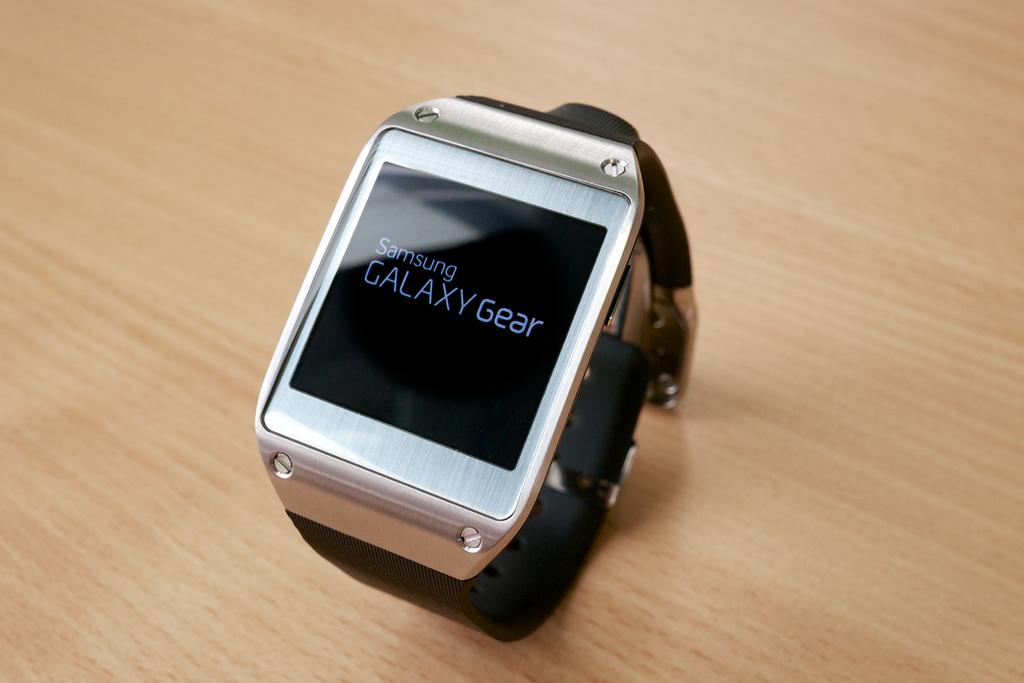What company makes this device?
Your answer should be compact. Samsung. What gear type is this?
Keep it short and to the point. Galaxy. 